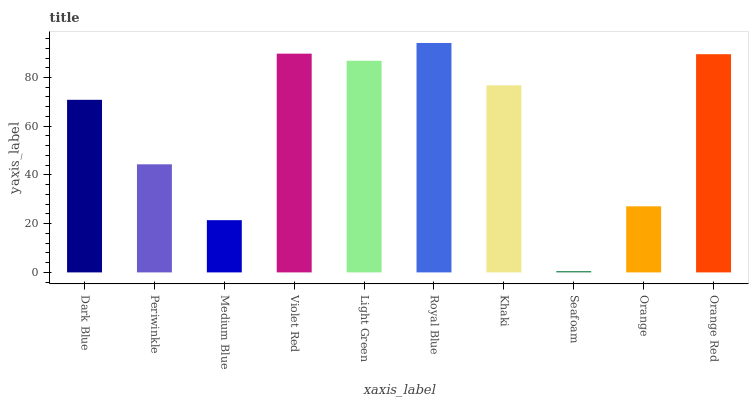Is Seafoam the minimum?
Answer yes or no. Yes. Is Royal Blue the maximum?
Answer yes or no. Yes. Is Periwinkle the minimum?
Answer yes or no. No. Is Periwinkle the maximum?
Answer yes or no. No. Is Dark Blue greater than Periwinkle?
Answer yes or no. Yes. Is Periwinkle less than Dark Blue?
Answer yes or no. Yes. Is Periwinkle greater than Dark Blue?
Answer yes or no. No. Is Dark Blue less than Periwinkle?
Answer yes or no. No. Is Khaki the high median?
Answer yes or no. Yes. Is Dark Blue the low median?
Answer yes or no. Yes. Is Seafoam the high median?
Answer yes or no. No. Is Seafoam the low median?
Answer yes or no. No. 